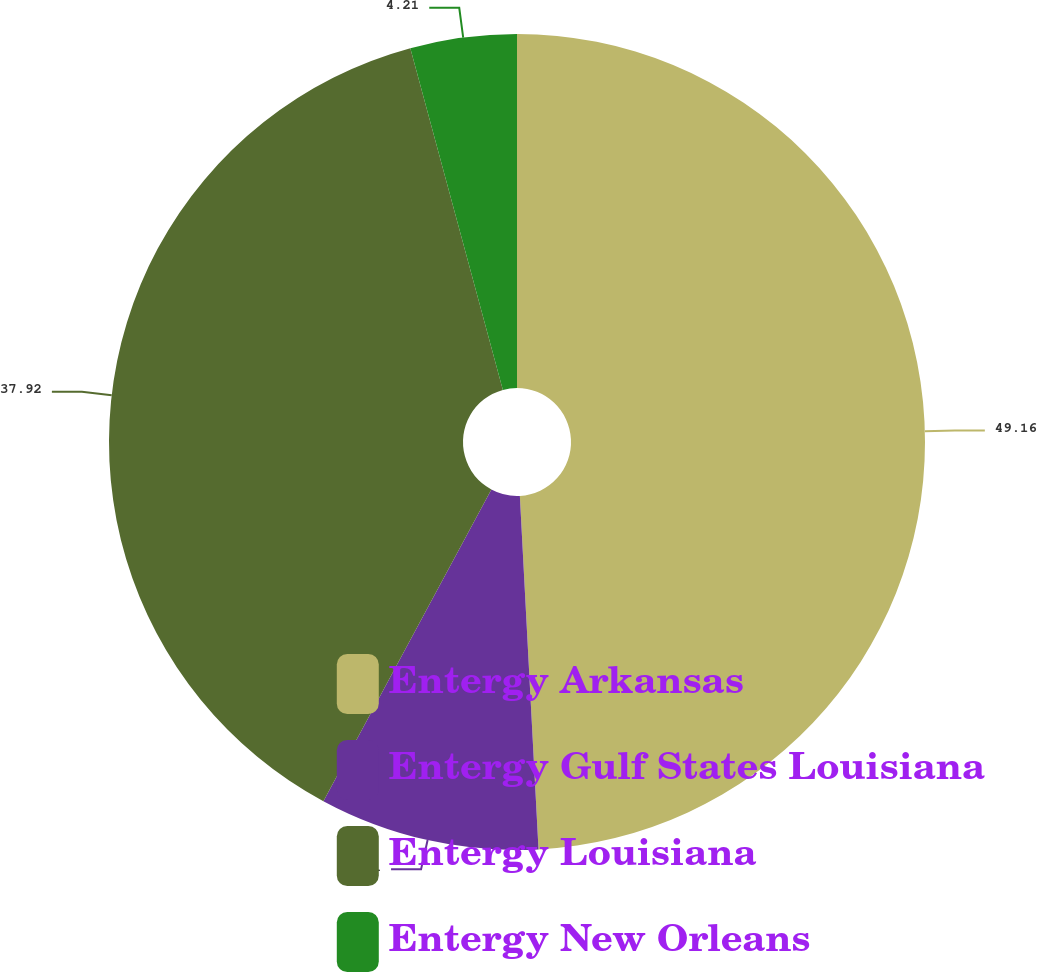<chart> <loc_0><loc_0><loc_500><loc_500><pie_chart><fcel>Entergy Arkansas<fcel>Entergy Gulf States Louisiana<fcel>Entergy Louisiana<fcel>Entergy New Orleans<nl><fcel>49.16%<fcel>8.71%<fcel>37.92%<fcel>4.21%<nl></chart> 